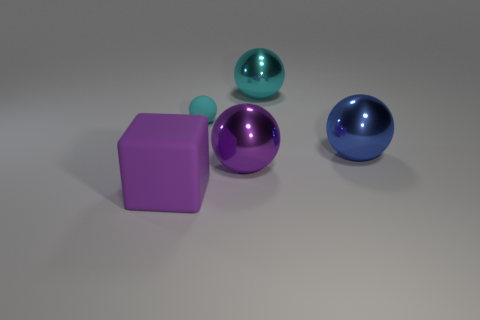Add 2 rubber objects. How many objects exist? 7 Subtract all yellow spheres. Subtract all cyan cylinders. How many spheres are left? 4 Subtract all cubes. How many objects are left? 4 Subtract all large green cubes. Subtract all large rubber blocks. How many objects are left? 4 Add 4 rubber things. How many rubber things are left? 6 Add 3 large metal balls. How many large metal balls exist? 6 Subtract 0 gray cubes. How many objects are left? 5 